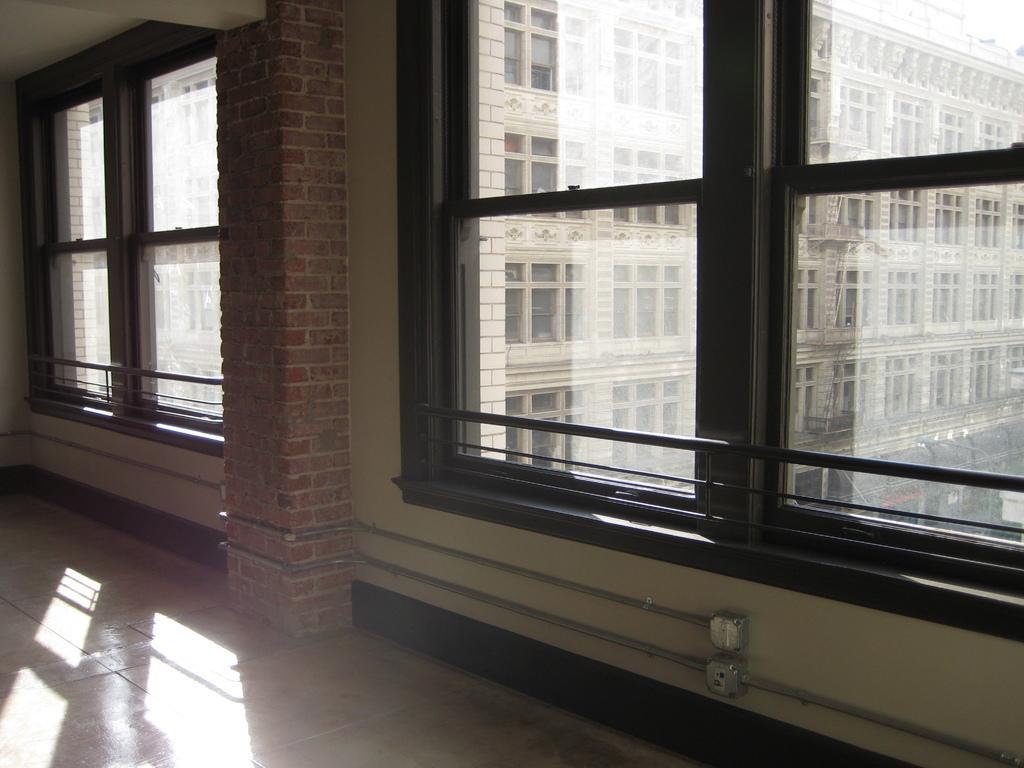In one or two sentences, can you explain what this image depicts? At the bottom of the image there is a floor. In the center of the image there is a pillar. In the background of the image there are glass windows through which we can see buildings. 